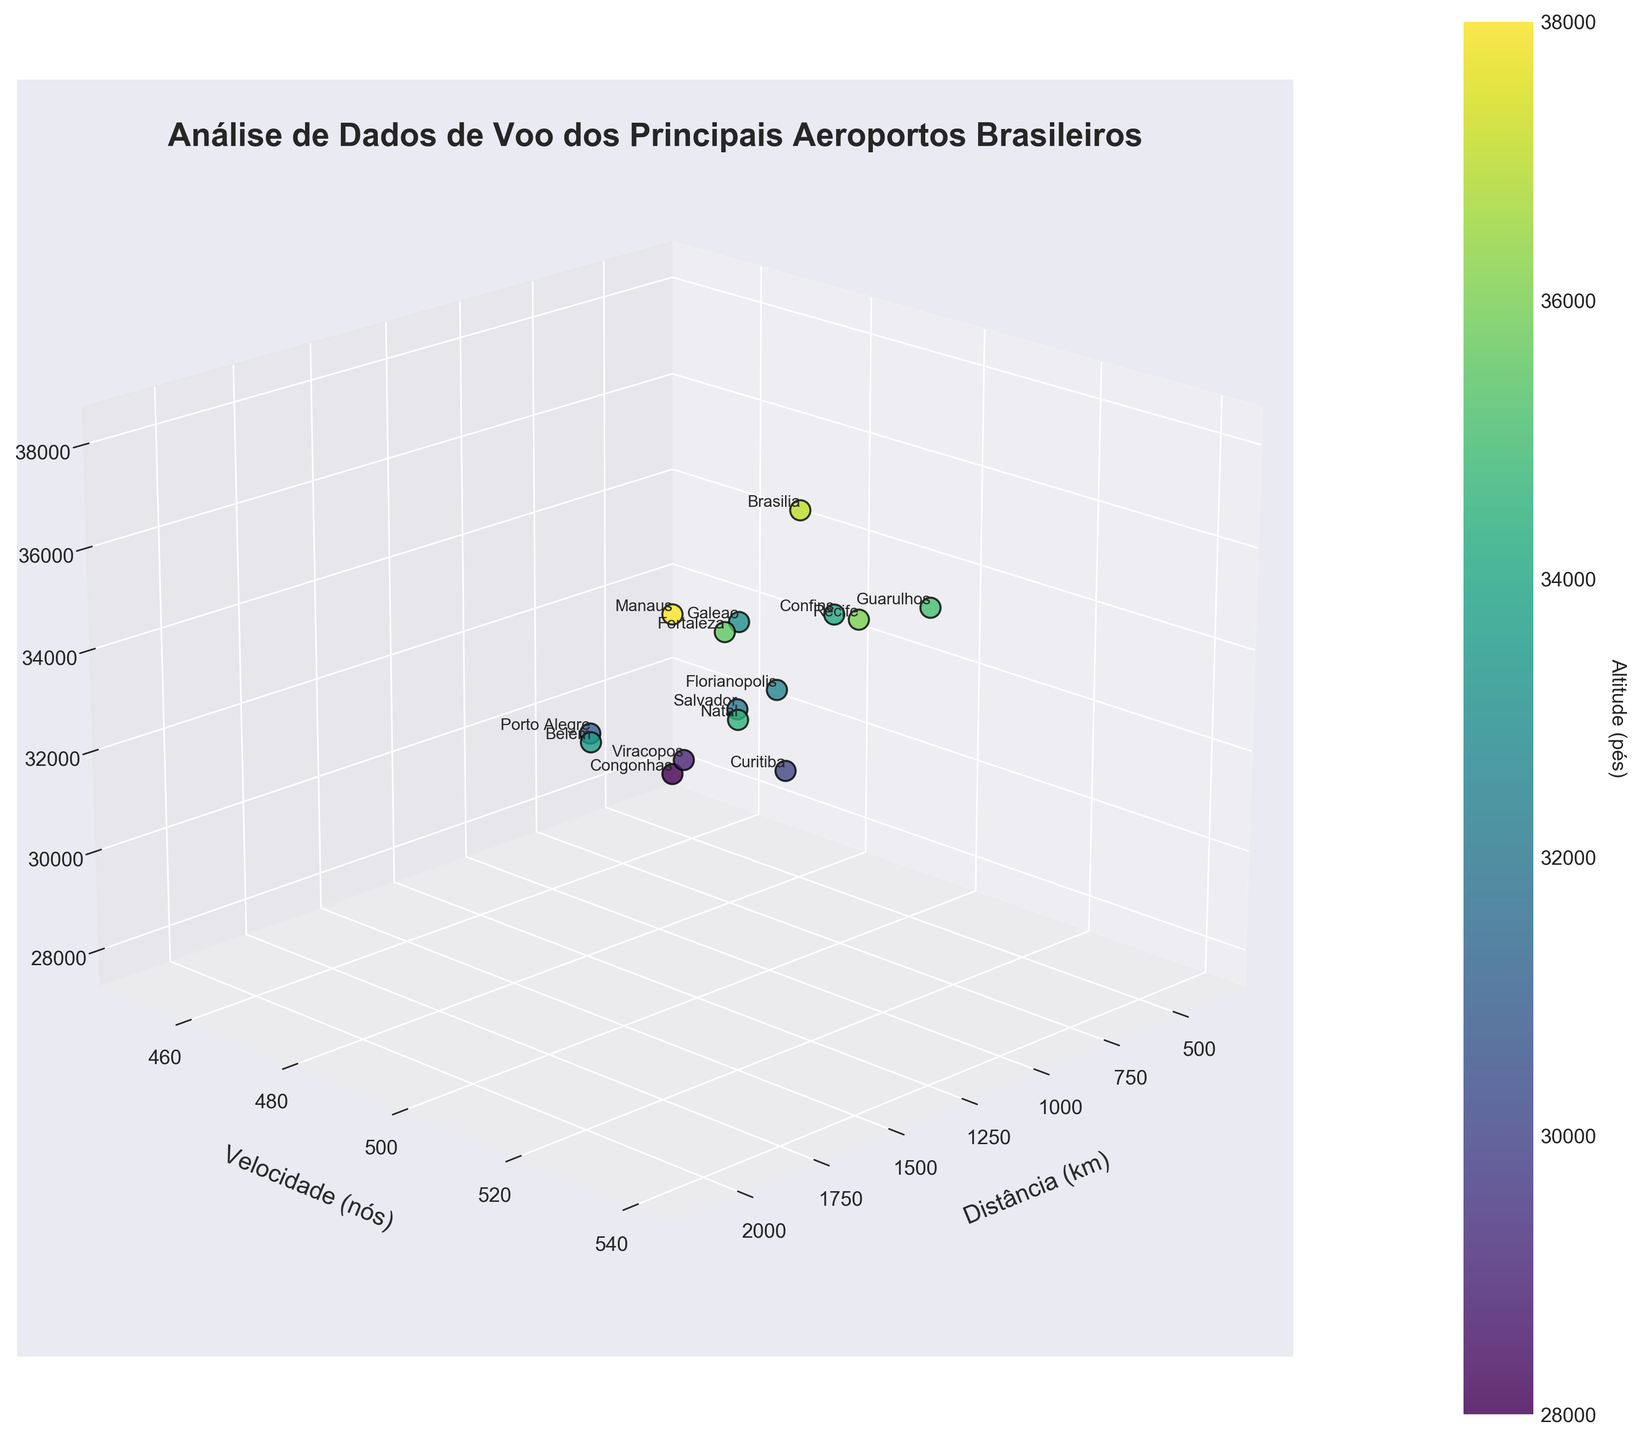How many airports are analyzed in the figure? To count the airports, look at the number of points plotted or the number of labels assigned to each point. Each point represents one airport.
Answer: 15 Which airport has the highest altitude? Find the point with the highest value on the altitude (z) axis and read its label. The highest point visually indicates the highest altitude.
Answer: Manaus What is the title of the figure? Look at the text at the top of the figure, which is generally larger and bold, to find the title.
Answer: Análise de Dados de Voo dos Principais Aeroportos Brasileiros Which airport has the lowest speed? Identify the point with the lowest value on the speed (y) axis and read its label. The lowest point visually indicates the lowest speed.
Answer: Congonhas Compare the speeds of Galeao and Belem. Which has a higher speed? Locate the points for Galeao and Belem, and compare their values on the speed (y) axis. The point closer to the top along the y-axis represents the higher speed.
Answer: Belem What color indicates higher altitudes in the figure? Look at the color bar and identify which end (top or bottom) corresponds to higher values. The colors will transition from one end to the other.
Answer: Yellow Which airport is farthest from the origin? Identify the point with the highest value on the distance (x) axis and read its label. The farthest point visually indicates the farthest distance from the origin.
Answer: Manaus What is the average altitude of all the airports? Sum all the altitude values and divide by the number of airports (15). Calculate: (35000 + 33000 + 37000 + 28000 + 32000 + 34000 + 31000 + 36000 + 35500 + 29000 + 38000 + 30000 + 33500 + 32500 + 34500) / 15. Detailed Calculation: Total Altitude = 531000, Average = 531000/15 = 35400 ft.
Answer: 35400 ft What is the total distance covered by all the flights? Sum up all the distance values from each airport. Calculation: 850 + 720 + 1100 + 380 + 920 + 780 + 1050 + 1300 + 1450 + 530 + 2100 + 650 + 1700 + 880 + 1600. Detailed Calculation: Total Distance = 15510 km.
Answer: 15510 km 